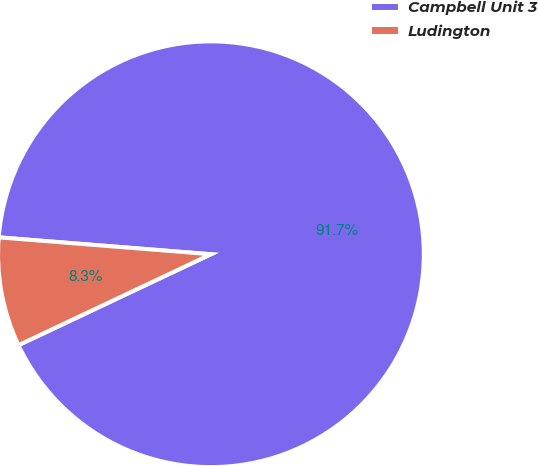<chart> <loc_0><loc_0><loc_500><loc_500><pie_chart><fcel>Campbell Unit 3<fcel>Ludington<nl><fcel>91.71%<fcel>8.29%<nl></chart> 